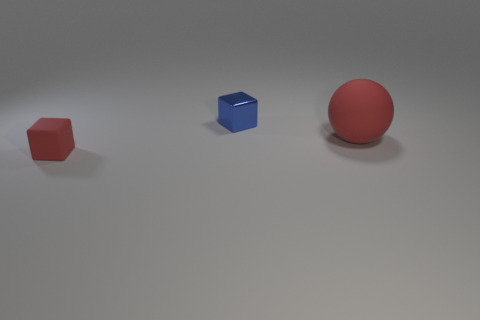Add 2 cyan cubes. How many objects exist? 5 Subtract all cubes. How many objects are left? 1 Subtract 1 spheres. How many spheres are left? 0 Add 3 tiny blue cubes. How many tiny blue cubes exist? 4 Subtract 0 cyan cylinders. How many objects are left? 3 Subtract all blue spheres. Subtract all brown cylinders. How many spheres are left? 1 Subtract all tiny blue objects. Subtract all small blue cubes. How many objects are left? 1 Add 1 small red cubes. How many small red cubes are left? 2 